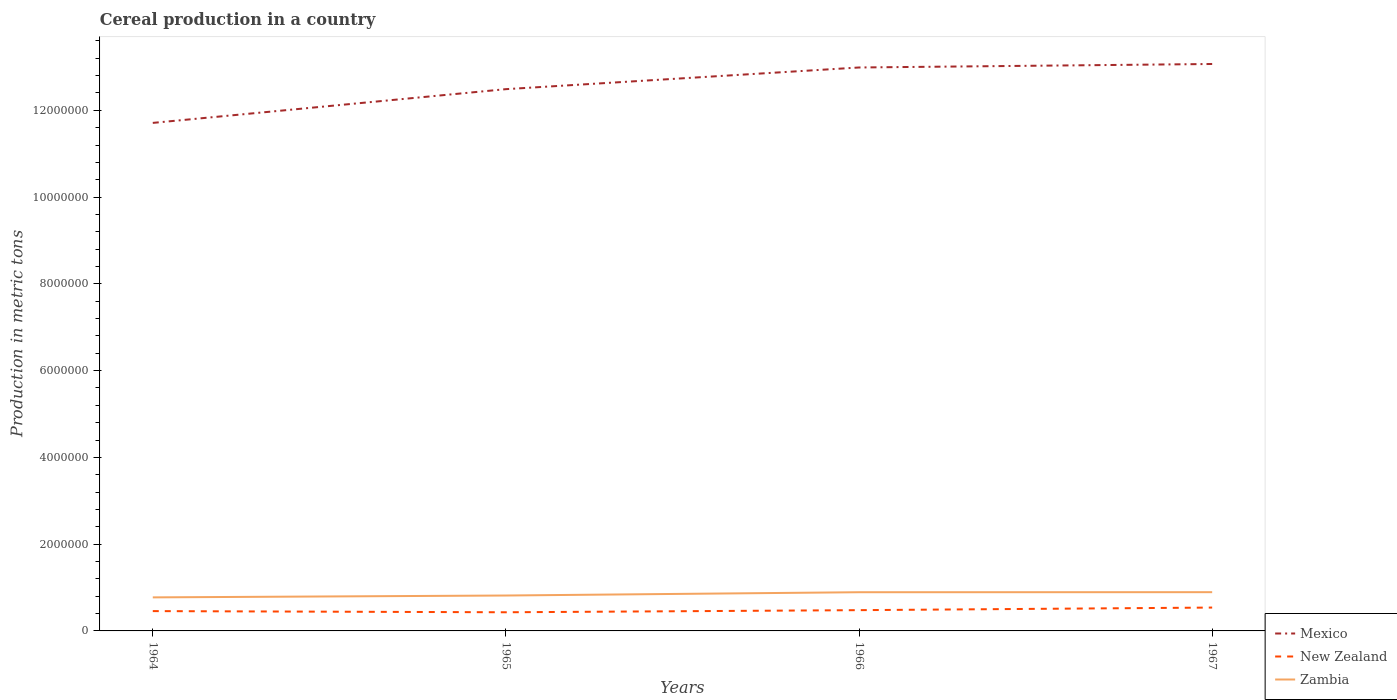How many different coloured lines are there?
Provide a short and direct response. 3. Is the number of lines equal to the number of legend labels?
Your answer should be very brief. Yes. Across all years, what is the maximum total cereal production in New Zealand?
Offer a very short reply. 4.30e+05. In which year was the total cereal production in Mexico maximum?
Keep it short and to the point. 1964. What is the total total cereal production in Zambia in the graph?
Keep it short and to the point. -4.30e+04. What is the difference between the highest and the second highest total cereal production in Zambia?
Make the answer very short. 1.20e+05. What is the difference between the highest and the lowest total cereal production in Zambia?
Offer a terse response. 2. Is the total cereal production in New Zealand strictly greater than the total cereal production in Zambia over the years?
Your answer should be compact. Yes. Are the values on the major ticks of Y-axis written in scientific E-notation?
Your response must be concise. No. Does the graph contain grids?
Your answer should be very brief. No. How are the legend labels stacked?
Your answer should be very brief. Vertical. What is the title of the graph?
Give a very brief answer. Cereal production in a country. What is the label or title of the Y-axis?
Your answer should be compact. Production in metric tons. What is the Production in metric tons in Mexico in 1964?
Provide a short and direct response. 1.17e+07. What is the Production in metric tons of New Zealand in 1964?
Offer a terse response. 4.57e+05. What is the Production in metric tons in Zambia in 1964?
Offer a very short reply. 7.73e+05. What is the Production in metric tons of Mexico in 1965?
Provide a short and direct response. 1.25e+07. What is the Production in metric tons in New Zealand in 1965?
Your response must be concise. 4.30e+05. What is the Production in metric tons of Zambia in 1965?
Provide a short and direct response. 8.16e+05. What is the Production in metric tons in Mexico in 1966?
Provide a short and direct response. 1.30e+07. What is the Production in metric tons of New Zealand in 1966?
Provide a succinct answer. 4.79e+05. What is the Production in metric tons in Zambia in 1966?
Make the answer very short. 8.92e+05. What is the Production in metric tons of Mexico in 1967?
Your response must be concise. 1.31e+07. What is the Production in metric tons in New Zealand in 1967?
Offer a terse response. 5.38e+05. What is the Production in metric tons in Zambia in 1967?
Offer a terse response. 8.93e+05. Across all years, what is the maximum Production in metric tons of Mexico?
Offer a very short reply. 1.31e+07. Across all years, what is the maximum Production in metric tons of New Zealand?
Keep it short and to the point. 5.38e+05. Across all years, what is the maximum Production in metric tons in Zambia?
Give a very brief answer. 8.93e+05. Across all years, what is the minimum Production in metric tons of Mexico?
Provide a succinct answer. 1.17e+07. Across all years, what is the minimum Production in metric tons of New Zealand?
Offer a terse response. 4.30e+05. Across all years, what is the minimum Production in metric tons of Zambia?
Give a very brief answer. 7.73e+05. What is the total Production in metric tons in Mexico in the graph?
Your answer should be compact. 5.03e+07. What is the total Production in metric tons in New Zealand in the graph?
Offer a very short reply. 1.90e+06. What is the total Production in metric tons in Zambia in the graph?
Ensure brevity in your answer.  3.37e+06. What is the difference between the Production in metric tons of Mexico in 1964 and that in 1965?
Your answer should be very brief. -7.78e+05. What is the difference between the Production in metric tons in New Zealand in 1964 and that in 1965?
Provide a succinct answer. 2.69e+04. What is the difference between the Production in metric tons of Zambia in 1964 and that in 1965?
Provide a short and direct response. -4.30e+04. What is the difference between the Production in metric tons in Mexico in 1964 and that in 1966?
Offer a terse response. -1.28e+06. What is the difference between the Production in metric tons of New Zealand in 1964 and that in 1966?
Provide a succinct answer. -2.18e+04. What is the difference between the Production in metric tons of Zambia in 1964 and that in 1966?
Ensure brevity in your answer.  -1.19e+05. What is the difference between the Production in metric tons in Mexico in 1964 and that in 1967?
Keep it short and to the point. -1.36e+06. What is the difference between the Production in metric tons of New Zealand in 1964 and that in 1967?
Provide a succinct answer. -8.15e+04. What is the difference between the Production in metric tons of Zambia in 1964 and that in 1967?
Provide a short and direct response. -1.20e+05. What is the difference between the Production in metric tons in Mexico in 1965 and that in 1966?
Your answer should be compact. -5.00e+05. What is the difference between the Production in metric tons of New Zealand in 1965 and that in 1966?
Provide a short and direct response. -4.87e+04. What is the difference between the Production in metric tons in Zambia in 1965 and that in 1966?
Provide a short and direct response. -7.59e+04. What is the difference between the Production in metric tons of Mexico in 1965 and that in 1967?
Provide a short and direct response. -5.80e+05. What is the difference between the Production in metric tons of New Zealand in 1965 and that in 1967?
Offer a very short reply. -1.08e+05. What is the difference between the Production in metric tons in Zambia in 1965 and that in 1967?
Make the answer very short. -7.70e+04. What is the difference between the Production in metric tons in Mexico in 1966 and that in 1967?
Your answer should be very brief. -8.05e+04. What is the difference between the Production in metric tons of New Zealand in 1966 and that in 1967?
Give a very brief answer. -5.97e+04. What is the difference between the Production in metric tons of Zambia in 1966 and that in 1967?
Offer a terse response. -1118. What is the difference between the Production in metric tons of Mexico in 1964 and the Production in metric tons of New Zealand in 1965?
Give a very brief answer. 1.13e+07. What is the difference between the Production in metric tons of Mexico in 1964 and the Production in metric tons of Zambia in 1965?
Keep it short and to the point. 1.09e+07. What is the difference between the Production in metric tons of New Zealand in 1964 and the Production in metric tons of Zambia in 1965?
Ensure brevity in your answer.  -3.59e+05. What is the difference between the Production in metric tons in Mexico in 1964 and the Production in metric tons in New Zealand in 1966?
Offer a very short reply. 1.12e+07. What is the difference between the Production in metric tons of Mexico in 1964 and the Production in metric tons of Zambia in 1966?
Offer a terse response. 1.08e+07. What is the difference between the Production in metric tons of New Zealand in 1964 and the Production in metric tons of Zambia in 1966?
Offer a very short reply. -4.35e+05. What is the difference between the Production in metric tons in Mexico in 1964 and the Production in metric tons in New Zealand in 1967?
Give a very brief answer. 1.12e+07. What is the difference between the Production in metric tons in Mexico in 1964 and the Production in metric tons in Zambia in 1967?
Keep it short and to the point. 1.08e+07. What is the difference between the Production in metric tons of New Zealand in 1964 and the Production in metric tons of Zambia in 1967?
Provide a short and direct response. -4.36e+05. What is the difference between the Production in metric tons in Mexico in 1965 and the Production in metric tons in New Zealand in 1966?
Your response must be concise. 1.20e+07. What is the difference between the Production in metric tons of Mexico in 1965 and the Production in metric tons of Zambia in 1966?
Your answer should be compact. 1.16e+07. What is the difference between the Production in metric tons in New Zealand in 1965 and the Production in metric tons in Zambia in 1966?
Ensure brevity in your answer.  -4.62e+05. What is the difference between the Production in metric tons of Mexico in 1965 and the Production in metric tons of New Zealand in 1967?
Provide a short and direct response. 1.19e+07. What is the difference between the Production in metric tons of Mexico in 1965 and the Production in metric tons of Zambia in 1967?
Provide a short and direct response. 1.16e+07. What is the difference between the Production in metric tons of New Zealand in 1965 and the Production in metric tons of Zambia in 1967?
Offer a very short reply. -4.63e+05. What is the difference between the Production in metric tons in Mexico in 1966 and the Production in metric tons in New Zealand in 1967?
Give a very brief answer. 1.24e+07. What is the difference between the Production in metric tons in Mexico in 1966 and the Production in metric tons in Zambia in 1967?
Your answer should be very brief. 1.21e+07. What is the difference between the Production in metric tons of New Zealand in 1966 and the Production in metric tons of Zambia in 1967?
Provide a succinct answer. -4.14e+05. What is the average Production in metric tons of Mexico per year?
Your answer should be compact. 1.26e+07. What is the average Production in metric tons in New Zealand per year?
Your answer should be very brief. 4.76e+05. What is the average Production in metric tons in Zambia per year?
Keep it short and to the point. 8.44e+05. In the year 1964, what is the difference between the Production in metric tons of Mexico and Production in metric tons of New Zealand?
Offer a terse response. 1.13e+07. In the year 1964, what is the difference between the Production in metric tons of Mexico and Production in metric tons of Zambia?
Your response must be concise. 1.09e+07. In the year 1964, what is the difference between the Production in metric tons in New Zealand and Production in metric tons in Zambia?
Give a very brief answer. -3.16e+05. In the year 1965, what is the difference between the Production in metric tons of Mexico and Production in metric tons of New Zealand?
Ensure brevity in your answer.  1.21e+07. In the year 1965, what is the difference between the Production in metric tons of Mexico and Production in metric tons of Zambia?
Provide a short and direct response. 1.17e+07. In the year 1965, what is the difference between the Production in metric tons in New Zealand and Production in metric tons in Zambia?
Your response must be concise. -3.86e+05. In the year 1966, what is the difference between the Production in metric tons in Mexico and Production in metric tons in New Zealand?
Keep it short and to the point. 1.25e+07. In the year 1966, what is the difference between the Production in metric tons in Mexico and Production in metric tons in Zambia?
Offer a very short reply. 1.21e+07. In the year 1966, what is the difference between the Production in metric tons of New Zealand and Production in metric tons of Zambia?
Provide a succinct answer. -4.13e+05. In the year 1967, what is the difference between the Production in metric tons of Mexico and Production in metric tons of New Zealand?
Provide a succinct answer. 1.25e+07. In the year 1967, what is the difference between the Production in metric tons of Mexico and Production in metric tons of Zambia?
Your response must be concise. 1.22e+07. In the year 1967, what is the difference between the Production in metric tons in New Zealand and Production in metric tons in Zambia?
Ensure brevity in your answer.  -3.55e+05. What is the ratio of the Production in metric tons of Mexico in 1964 to that in 1965?
Provide a short and direct response. 0.94. What is the ratio of the Production in metric tons of Zambia in 1964 to that in 1965?
Your response must be concise. 0.95. What is the ratio of the Production in metric tons of Mexico in 1964 to that in 1966?
Your answer should be compact. 0.9. What is the ratio of the Production in metric tons of New Zealand in 1964 to that in 1966?
Keep it short and to the point. 0.95. What is the ratio of the Production in metric tons in Zambia in 1964 to that in 1966?
Offer a terse response. 0.87. What is the ratio of the Production in metric tons of Mexico in 1964 to that in 1967?
Provide a short and direct response. 0.9. What is the ratio of the Production in metric tons in New Zealand in 1964 to that in 1967?
Offer a terse response. 0.85. What is the ratio of the Production in metric tons in Zambia in 1964 to that in 1967?
Offer a terse response. 0.87. What is the ratio of the Production in metric tons of Mexico in 1965 to that in 1966?
Give a very brief answer. 0.96. What is the ratio of the Production in metric tons in New Zealand in 1965 to that in 1966?
Provide a short and direct response. 0.9. What is the ratio of the Production in metric tons in Zambia in 1965 to that in 1966?
Provide a succinct answer. 0.92. What is the ratio of the Production in metric tons in Mexico in 1965 to that in 1967?
Offer a terse response. 0.96. What is the ratio of the Production in metric tons in New Zealand in 1965 to that in 1967?
Offer a terse response. 0.8. What is the ratio of the Production in metric tons of Zambia in 1965 to that in 1967?
Your answer should be compact. 0.91. What is the ratio of the Production in metric tons of Mexico in 1966 to that in 1967?
Keep it short and to the point. 0.99. What is the ratio of the Production in metric tons in New Zealand in 1966 to that in 1967?
Offer a very short reply. 0.89. What is the difference between the highest and the second highest Production in metric tons of Mexico?
Give a very brief answer. 8.05e+04. What is the difference between the highest and the second highest Production in metric tons in New Zealand?
Offer a very short reply. 5.97e+04. What is the difference between the highest and the second highest Production in metric tons of Zambia?
Your answer should be very brief. 1118. What is the difference between the highest and the lowest Production in metric tons of Mexico?
Keep it short and to the point. 1.36e+06. What is the difference between the highest and the lowest Production in metric tons in New Zealand?
Give a very brief answer. 1.08e+05. What is the difference between the highest and the lowest Production in metric tons of Zambia?
Your answer should be very brief. 1.20e+05. 